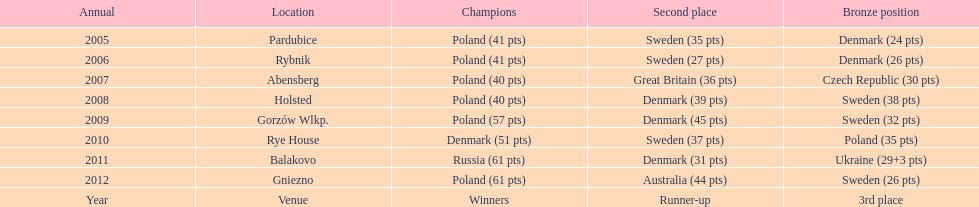Which team has the most third place wins in the speedway junior world championship between 2005 and 2012? Sweden. 